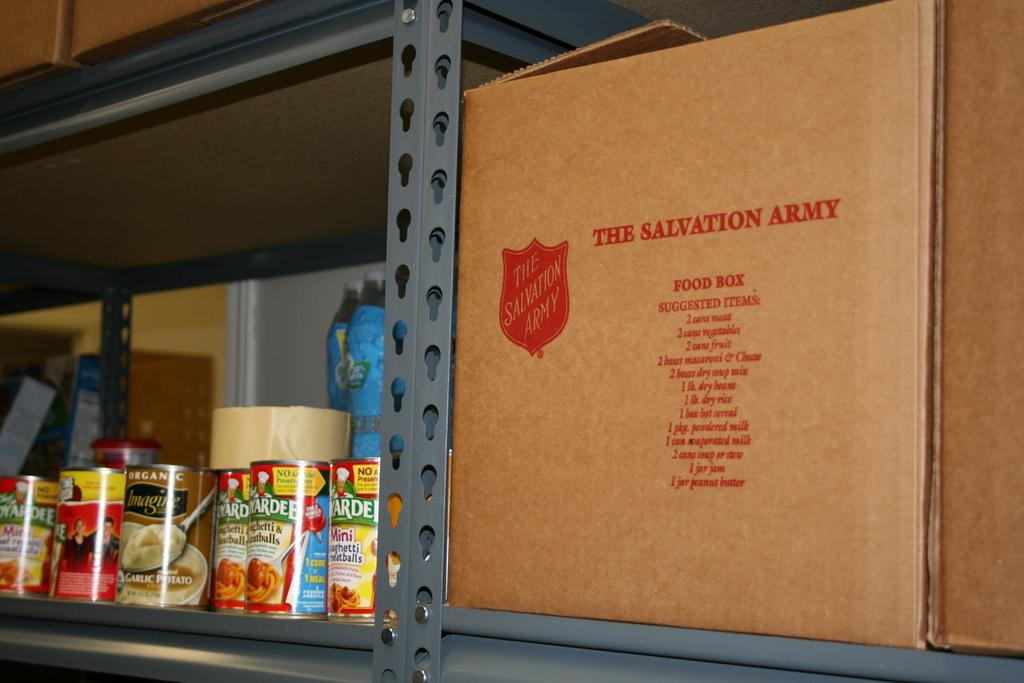<image>
Write a terse but informative summary of the picture. Canned goods for the Salvation Army on stacked on metal shelves. 